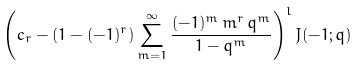<formula> <loc_0><loc_0><loc_500><loc_500>\left ( c _ { r } - \left ( 1 - ( - 1 ) ^ { r } \right ) \sum _ { m = 1 } ^ { \infty } \frac { ( - 1 ) ^ { m } \, m ^ { r } \, q ^ { m } } { 1 - q ^ { m } } \right ) ^ { l } J ( - 1 ; q )</formula> 